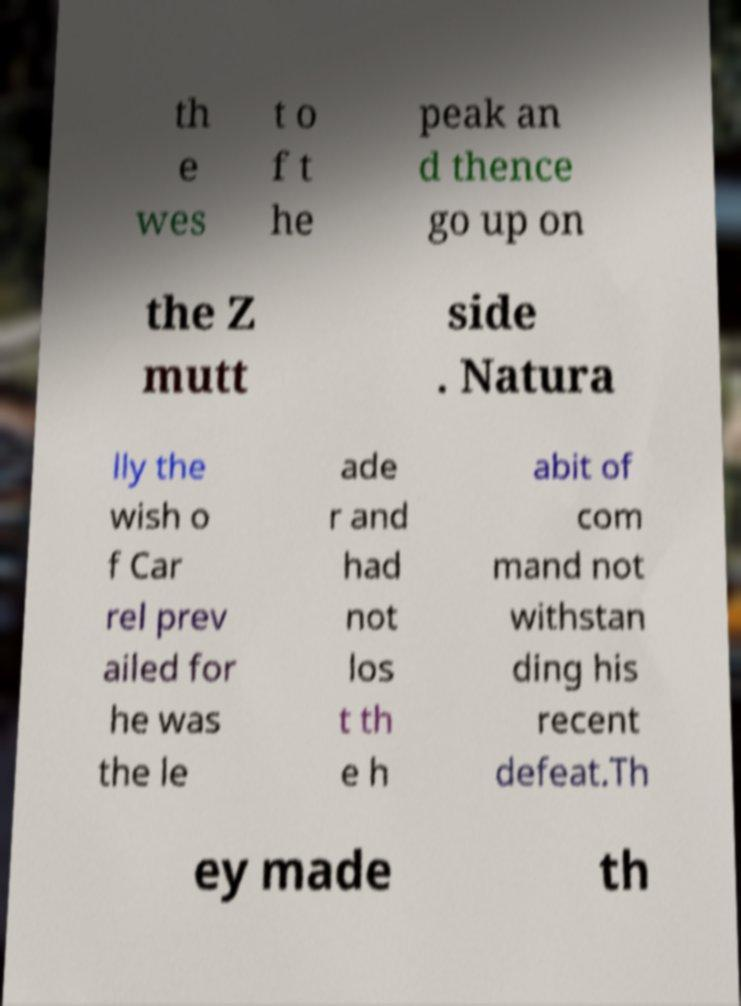Can you accurately transcribe the text from the provided image for me? th e wes t o f t he peak an d thence go up on the Z mutt side . Natura lly the wish o f Car rel prev ailed for he was the le ade r and had not los t th e h abit of com mand not withstan ding his recent defeat.Th ey made th 